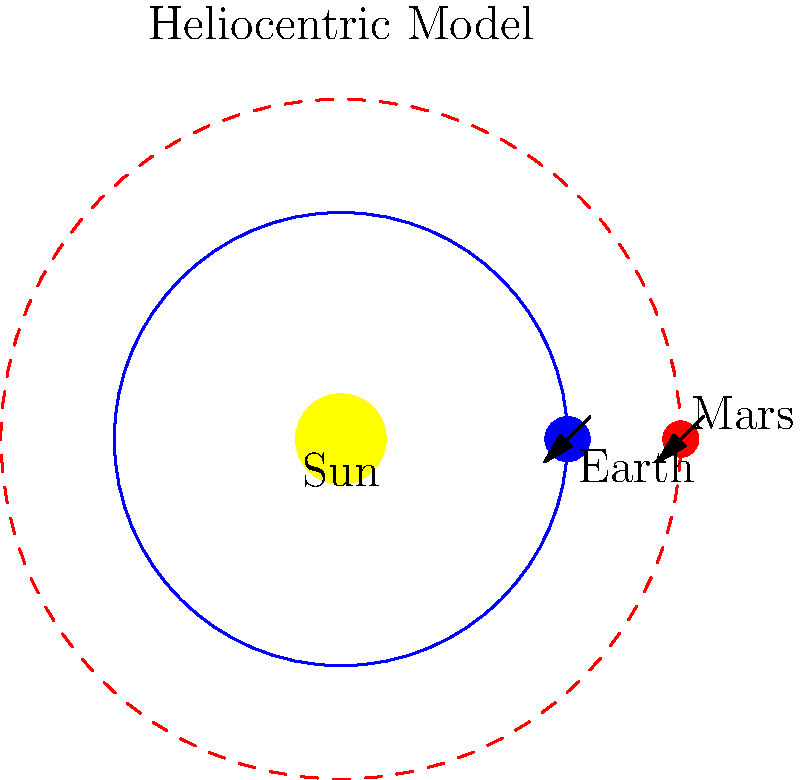In the 17th century, the debate between the geocentric and heliocentric models of the solar system was a contentious topic. Based on the diagram shown, which represents the heliocentric model, how would this system explain the apparent retrograde motion of Mars as observed from Earth? To understand the explanation of retrograde motion in the heliocentric model, let's follow these steps:

1. In the heliocentric model, both Earth and Mars orbit the Sun, with Earth's orbit being inner and faster than Mars'.

2. Earth's orbital period is approximately 365 days, while Mars' is about 687 days. This means Earth completes its orbit more quickly than Mars.

3. As Earth moves in its orbit, it periodically overtakes Mars. During this time, the relative positions of Earth, Mars, and the background stars change.

4. When Earth is approaching the point of overtaking Mars:
   a. Mars appears to move in its usual direction (prograde motion) against the background stars.

5. As Earth passes Mars:
   a. From Earth's perspective, Mars appears to slow down, stop, and then move backward (retrograde motion) relative to the background stars.

6. After Earth has moved sufficiently ahead of Mars:
   a. Mars appears to slow its backward motion, stop, and then resume its forward motion against the background stars.

7. This entire process is an optical illusion caused by the changing viewing angle from Earth as both planets move in their orbits around the Sun.

8. The heliocentric model elegantly explains this phenomenon without requiring complex epicycles or deferents, as was necessary in the geocentric model.

This explanation of retrograde motion was one of the key advantages of the heliocentric model over the geocentric model, contributing to its eventual acceptance in the scientific community during and after the 17th century.
Answer: Relative orbital speeds and positions 